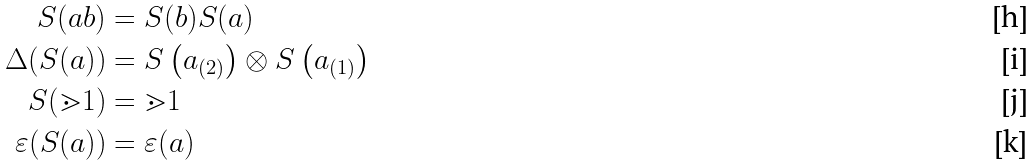<formula> <loc_0><loc_0><loc_500><loc_500>S ( a b ) & = S ( b ) S ( a ) \\ \Delta ( S ( a ) ) & = S \left ( a _ { ( 2 ) } \right ) \otimes S \left ( a _ { ( 1 ) } \right ) \\ S ( \mathbb { m } { 1 } ) & = \mathbb { m } { 1 } \\ \varepsilon ( S ( a ) ) & = \varepsilon ( a )</formula> 